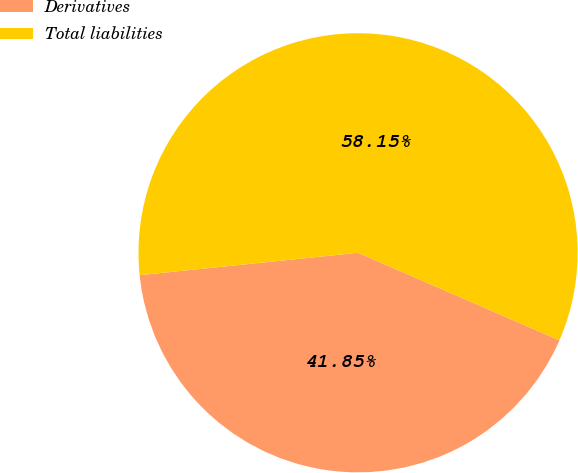Convert chart to OTSL. <chart><loc_0><loc_0><loc_500><loc_500><pie_chart><fcel>Derivatives<fcel>Total liabilities<nl><fcel>41.85%<fcel>58.15%<nl></chart> 